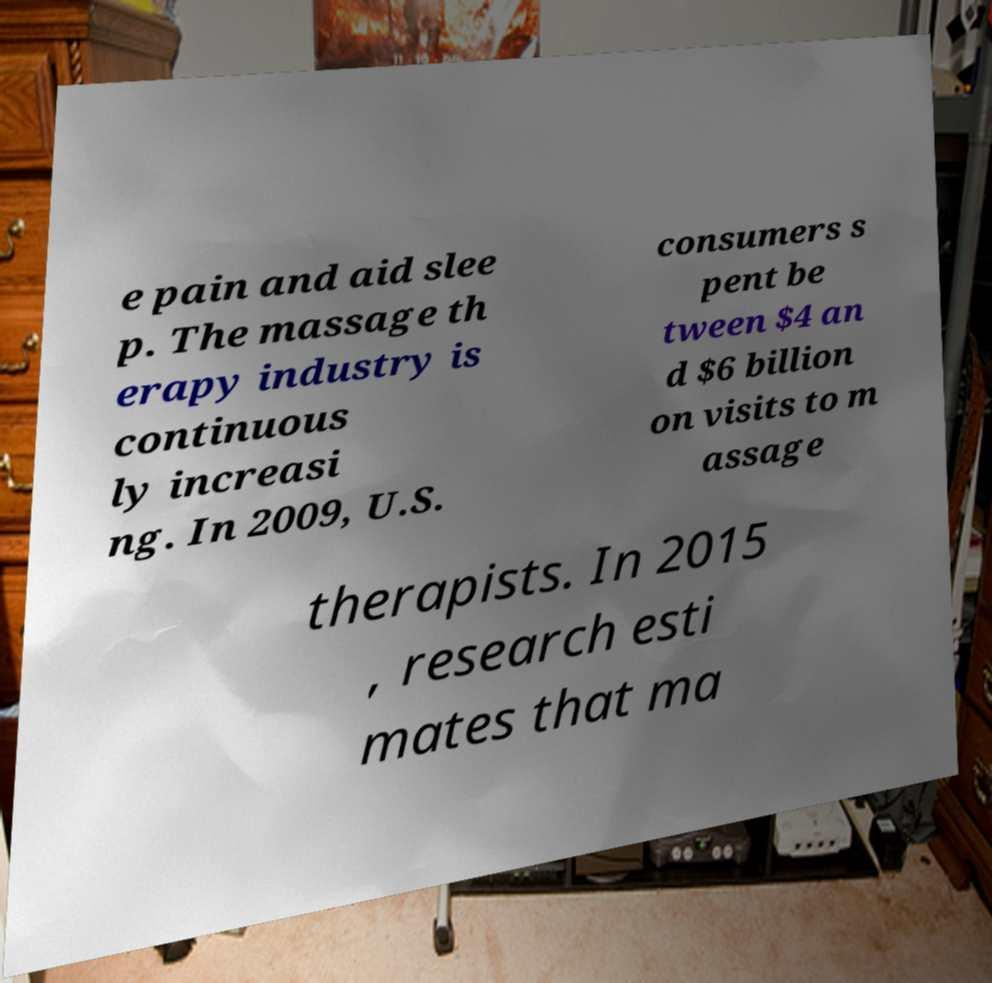Could you extract and type out the text from this image? e pain and aid slee p. The massage th erapy industry is continuous ly increasi ng. In 2009, U.S. consumers s pent be tween $4 an d $6 billion on visits to m assage therapists. In 2015 , research esti mates that ma 